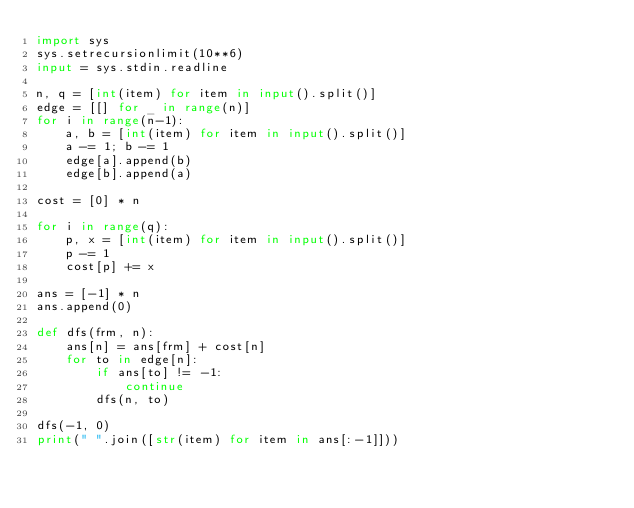<code> <loc_0><loc_0><loc_500><loc_500><_Python_>import sys
sys.setrecursionlimit(10**6)
input = sys.stdin.readline

n, q = [int(item) for item in input().split()]
edge = [[] for _ in range(n)]
for i in range(n-1):
    a, b = [int(item) for item in input().split()]
    a -= 1; b -= 1
    edge[a].append(b)
    edge[b].append(a)

cost = [0] * n

for i in range(q):
    p, x = [int(item) for item in input().split()]
    p -= 1
    cost[p] += x

ans = [-1] * n
ans.append(0)

def dfs(frm, n):
    ans[n] = ans[frm] + cost[n]
    for to in edge[n]:
        if ans[to] != -1:
            continue
        dfs(n, to)

dfs(-1, 0)
print(" ".join([str(item) for item in ans[:-1]]))</code> 